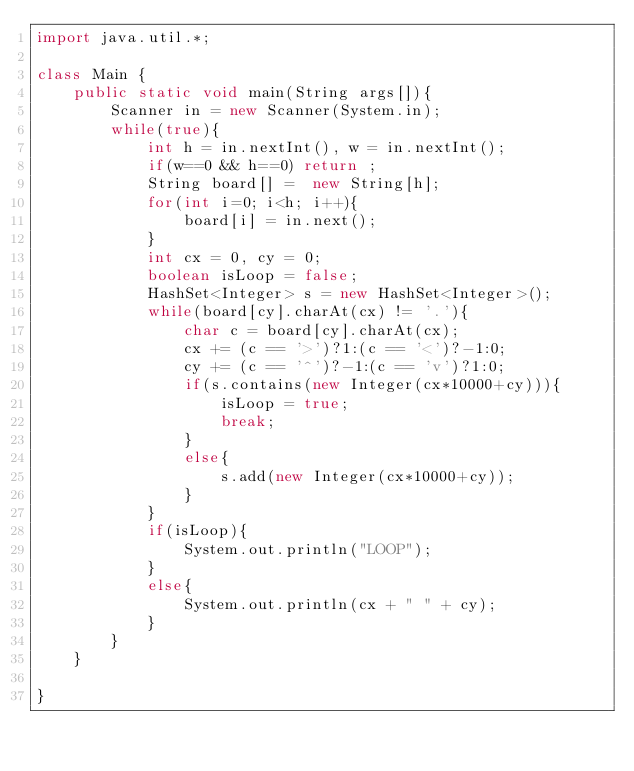Convert code to text. <code><loc_0><loc_0><loc_500><loc_500><_Java_>import java.util.*;

class Main {
	public static void main(String args[]){
		Scanner in = new Scanner(System.in);
		while(true){
			int h = in.nextInt(), w = in.nextInt();
			if(w==0 && h==0) return ;
			String board[] =  new String[h];
			for(int i=0; i<h; i++){
				board[i] = in.next();
			}
			int cx = 0, cy = 0;
			boolean isLoop = false;
			HashSet<Integer> s = new HashSet<Integer>();
			while(board[cy].charAt(cx) != '.'){
				char c = board[cy].charAt(cx);
				cx += (c == '>')?1:(c == '<')?-1:0;
				cy += (c == '^')?-1:(c == 'v')?1:0;
				if(s.contains(new Integer(cx*10000+cy))){
					isLoop = true;
					break;
				}
				else{
					s.add(new Integer(cx*10000+cy));
				}
			}
			if(isLoop){
				System.out.println("LOOP");
			}
			else{
				System.out.println(cx + " " + cy);
			}
		}
	}
	
}</code> 